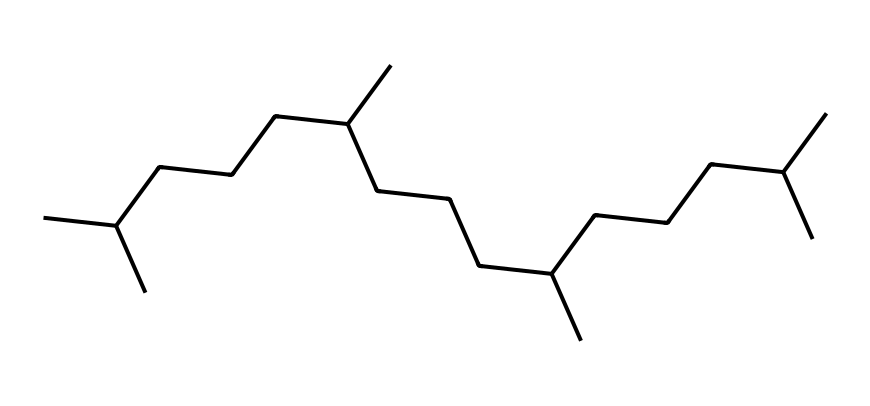What type of lipid does this structure represent? The long carbon chain and branching points indicate it is a triglyceride, a common type of lipid found in synthetic oils.
Answer: triglyceride How many carbon atoms are present in this structure? By counting each 'C' in the SMILES representation, there are 36 carbon atoms in total.
Answer: 36 What is the general property of this lipid related to its saturation? The lack of double bonds between carbon atoms in the structure indicates that it is saturated.
Answer: saturated How many hydrogen atoms are attached to this lipid's carbon backbone? Each carbon in a saturated chain generally bonds with enough hydrogens to form four total bonds; thus, there would be 74 hydrogens for 36 carbons (using the formula CnH2n+2).
Answer: 74 Why is this lipid structure significant for motor oil performance? The branched structure increases fluidity and stability at high temperatures, making it advantageous for lubrication in engines.
Answer: fluidity and stability What type of additives might be used with this lipid in motor oil formulations? Additives such as detergents, anti-wear agents, and anti-oxidants are commonly used to enhance the performance and stability of synthetic motor oils.
Answer: detergents, anti-wear agents, anti-oxidants How does the branching in this structure affect its physical properties? The branching decreases the packing efficiency of the molecules, resulting in lower viscosity and improved flow at low temperatures.
Answer: lower viscosity 